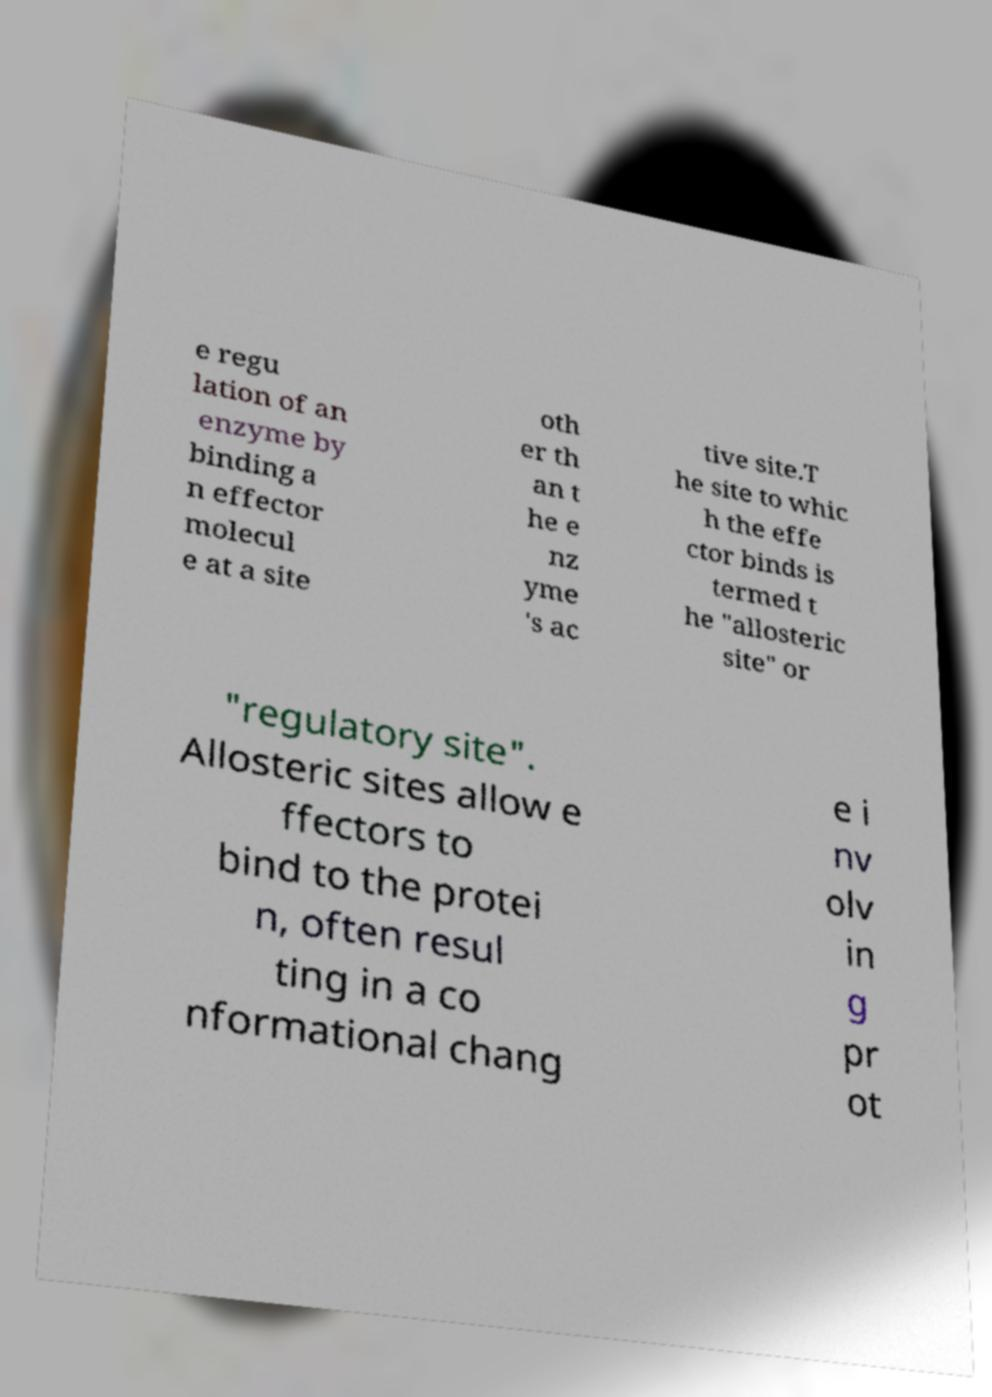I need the written content from this picture converted into text. Can you do that? e regu lation of an enzyme by binding a n effector molecul e at a site oth er th an t he e nz yme 's ac tive site.T he site to whic h the effe ctor binds is termed t he "allosteric site" or "regulatory site". Allosteric sites allow e ffectors to bind to the protei n, often resul ting in a co nformational chang e i nv olv in g pr ot 